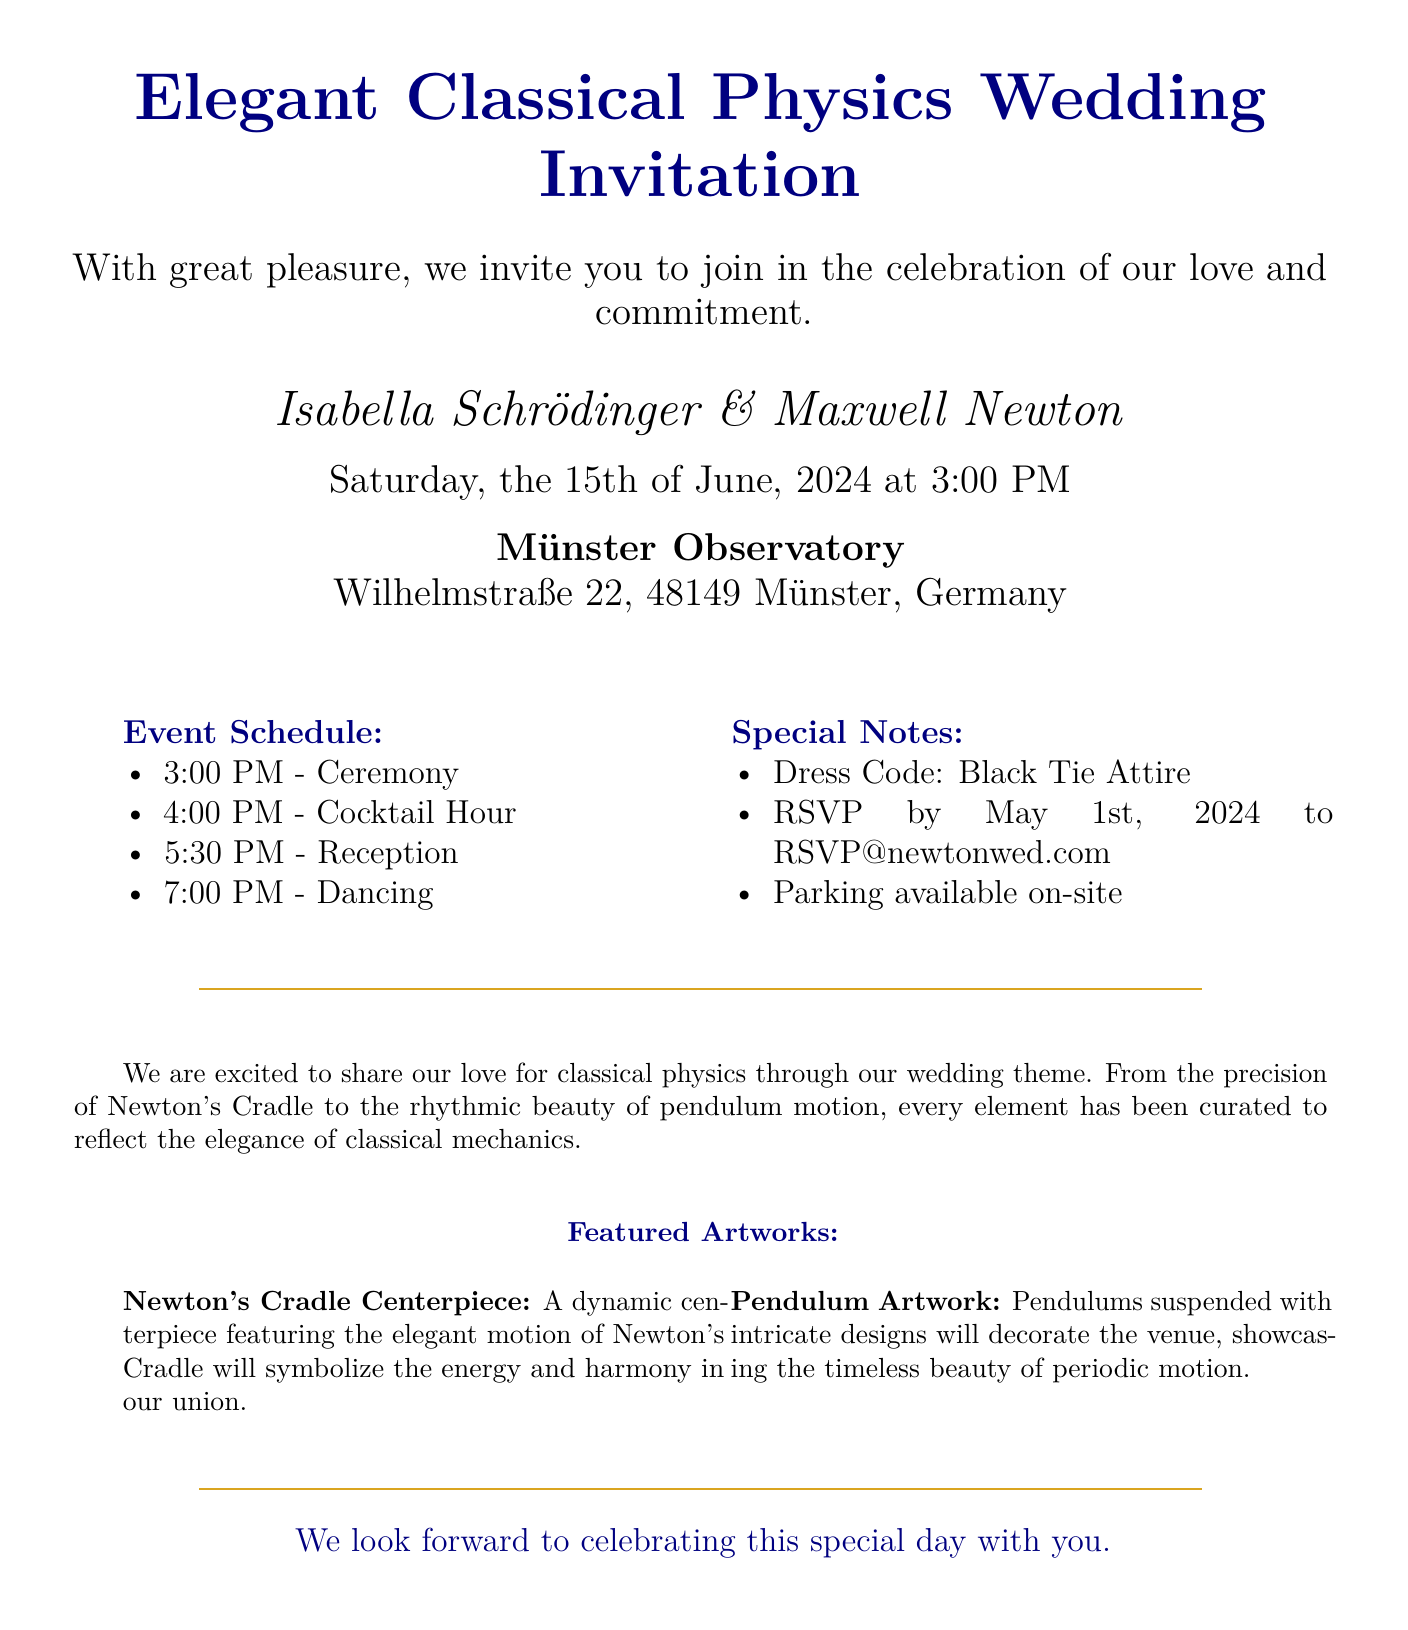What are the names of the couple? The names of the couple are mentioned prominently in the invitation section of the document.
Answer: Isabella Schrödinger & Maxwell Newton What is the date of the wedding? The date is clearly stated in the invitation section, indicating when the event will take place.
Answer: Saturday, the 15th of June, 2024 What is the time of the ceremony? The ceremony time is listed in the event schedule providing the start time of the main event.
Answer: 3:00 PM Where is the wedding venue? The wedding venue address is specified in the invitation section, indicating where the event will occur.
Answer: Münster Observatory, Wilhelmstraße 22, 48149 Münster, Germany What is the dress code for the event? The dress code is highlighted in the special notes section of the document, guiding guests on appropriate attire.
Answer: Black Tie Attire What will be the event held after the cocktail hour? The event schedule enumerates the order of activities, including what follows the cocktail hour.
Answer: Reception What is the RSVP deadline? The RSVP deadline is explicitly mentioned in the special notes section for guests' responses.
Answer: May 1st, 2024 What symbolizes energy and harmony in the wedding theme? The wedding theme includes a specific element that represents these qualities, as described in the document.
Answer: Newton's Cradle Centerpiece What type of artwork will decorate the venue? The document specifies particular artworks that will adorn the venue, which enhances the wedding theme.
Answer: Pendulum Artwork What color is used for the text in the title? The title text color is described in the document, giving it a distinguished appearance.
Answer: Navy blue 